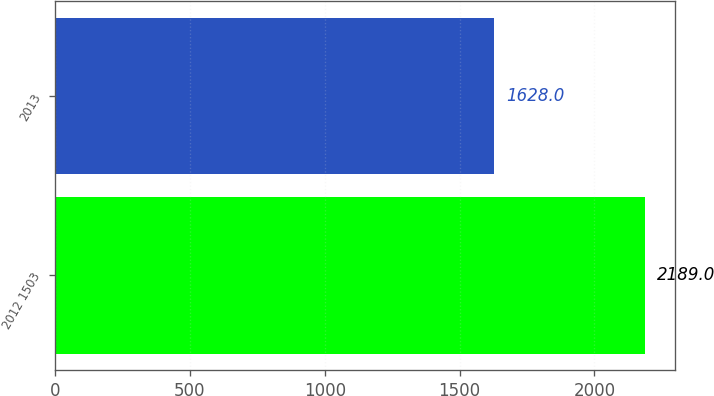Convert chart. <chart><loc_0><loc_0><loc_500><loc_500><bar_chart><fcel>2012 1503<fcel>2013<nl><fcel>2189<fcel>1628<nl></chart> 